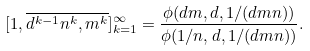Convert formula to latex. <formula><loc_0><loc_0><loc_500><loc_500>[ 1 , \overline { d ^ { k - 1 } n ^ { k } , m ^ { k } } ] _ { k = 1 } ^ { \infty } = \frac { \phi ( d m , d , 1 / ( d m n ) ) } { \phi ( 1 / n , d , 1 / ( d m n ) ) } .</formula> 